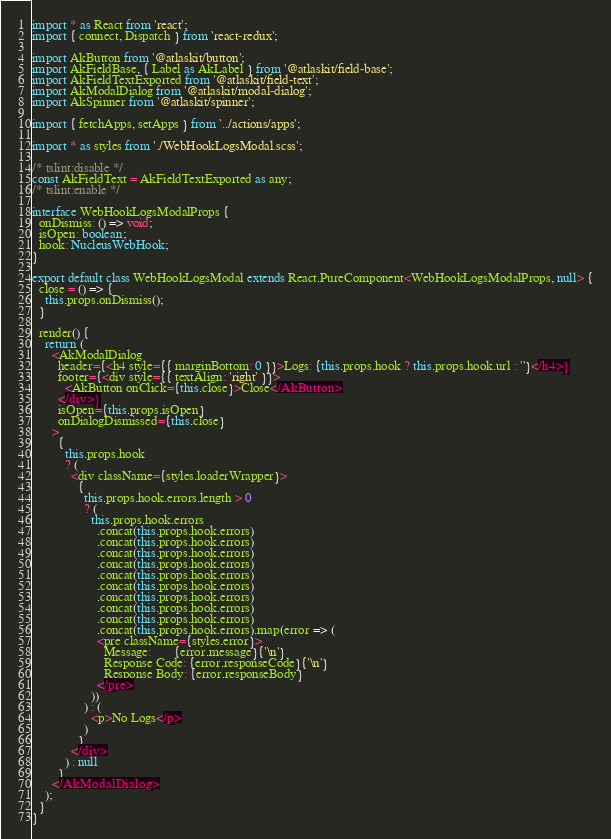Convert code to text. <code><loc_0><loc_0><loc_500><loc_500><_TypeScript_>import * as React from 'react';
import { connect, Dispatch } from 'react-redux';

import AkButton from '@atlaskit/button';
import AkFieldBase, { Label as AkLabel } from '@atlaskit/field-base';
import AkFieldTextExported from '@atlaskit/field-text';
import AkModalDialog from '@atlaskit/modal-dialog';
import AkSpinner from '@atlaskit/spinner';

import { fetchApps, setApps } from '../actions/apps';

import * as styles from './WebHookLogsModal.scss';

/* tslint:disable */
const AkFieldText = AkFieldTextExported as any;
/* tslint:enable */

interface WebHookLogsModalProps {
  onDismiss: () => void;
  isOpen: boolean;
  hook: NucleusWebHook;
}

export default class WebHookLogsModal extends React.PureComponent<WebHookLogsModalProps, null> {
  close = () => {
    this.props.onDismiss();
  }

  render() {
    return (
      <AkModalDialog
        header={<h4 style={{ marginBottom: 0 }}>Logs: {this.props.hook ? this.props.hook.url : ''}</h4>}
        footer={<div style={{ textAlign: 'right' }}>
          <AkButton onClick={this.close}>Close</AkButton>
        </div>}
        isOpen={this.props.isOpen}
        onDialogDismissed={this.close}
      >
        {
          this.props.hook
          ? (
            <div className={styles.loaderWrapper}>
              {
                this.props.hook.errors.length > 0
                ? (
                  this.props.hook.errors
                    .concat(this.props.hook.errors)
                    .concat(this.props.hook.errors)
                    .concat(this.props.hook.errors)
                    .concat(this.props.hook.errors)
                    .concat(this.props.hook.errors)
                    .concat(this.props.hook.errors)
                    .concat(this.props.hook.errors)
                    .concat(this.props.hook.errors)
                    .concat(this.props.hook.errors)
                    .concat(this.props.hook.errors).map(error => (
                    <pre className={styles.error}>
                      Message:       {error.message}{'\n'}
                      Response Code: {error.responseCode}{'\n'}
                      Response Body: {error.responseBody}
                    </pre>
                  ))
                ) : (
                  <p>No Logs</p>
                )
              }
            </div>
          ) : null
        }
      </AkModalDialog>
    );
  }
}
</code> 